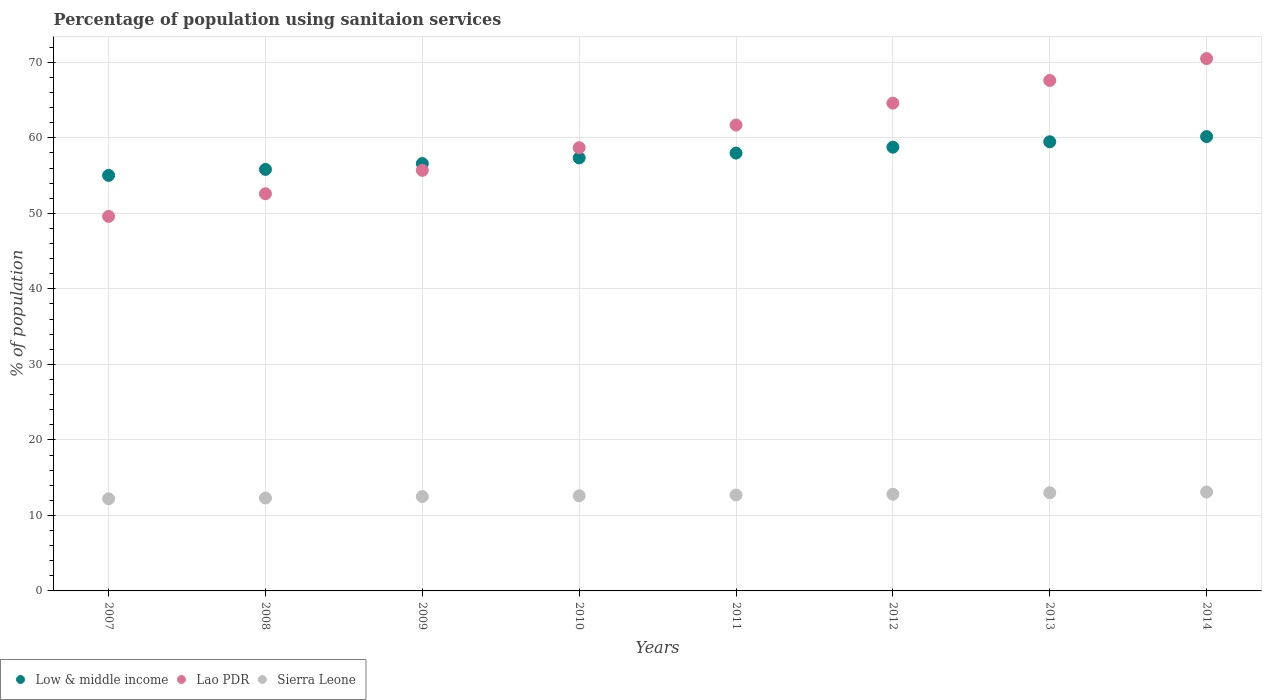How many different coloured dotlines are there?
Keep it short and to the point. 3. Is the number of dotlines equal to the number of legend labels?
Your answer should be compact. Yes. What is the percentage of population using sanitaion services in Low & middle income in 2008?
Give a very brief answer. 55.82. Across all years, what is the maximum percentage of population using sanitaion services in Lao PDR?
Your response must be concise. 70.5. Across all years, what is the minimum percentage of population using sanitaion services in Lao PDR?
Provide a short and direct response. 49.6. In which year was the percentage of population using sanitaion services in Low & middle income maximum?
Make the answer very short. 2014. In which year was the percentage of population using sanitaion services in Low & middle income minimum?
Ensure brevity in your answer.  2007. What is the total percentage of population using sanitaion services in Low & middle income in the graph?
Your answer should be compact. 461.2. What is the difference between the percentage of population using sanitaion services in Lao PDR in 2007 and that in 2013?
Your answer should be compact. -18. What is the difference between the percentage of population using sanitaion services in Low & middle income in 2012 and the percentage of population using sanitaion services in Sierra Leone in 2007?
Make the answer very short. 46.57. What is the average percentage of population using sanitaion services in Low & middle income per year?
Make the answer very short. 57.65. In the year 2012, what is the difference between the percentage of population using sanitaion services in Low & middle income and percentage of population using sanitaion services in Lao PDR?
Give a very brief answer. -5.83. In how many years, is the percentage of population using sanitaion services in Lao PDR greater than 50 %?
Keep it short and to the point. 7. What is the ratio of the percentage of population using sanitaion services in Sierra Leone in 2010 to that in 2013?
Offer a terse response. 0.97. Is the difference between the percentage of population using sanitaion services in Low & middle income in 2007 and 2008 greater than the difference between the percentage of population using sanitaion services in Lao PDR in 2007 and 2008?
Provide a short and direct response. Yes. What is the difference between the highest and the second highest percentage of population using sanitaion services in Sierra Leone?
Your answer should be compact. 0.1. What is the difference between the highest and the lowest percentage of population using sanitaion services in Lao PDR?
Your answer should be compact. 20.9. In how many years, is the percentage of population using sanitaion services in Sierra Leone greater than the average percentage of population using sanitaion services in Sierra Leone taken over all years?
Provide a short and direct response. 4. Is the percentage of population using sanitaion services in Sierra Leone strictly less than the percentage of population using sanitaion services in Low & middle income over the years?
Make the answer very short. Yes. How many dotlines are there?
Keep it short and to the point. 3. Are the values on the major ticks of Y-axis written in scientific E-notation?
Offer a very short reply. No. Does the graph contain any zero values?
Your response must be concise. No. How many legend labels are there?
Keep it short and to the point. 3. How are the legend labels stacked?
Your response must be concise. Horizontal. What is the title of the graph?
Your response must be concise. Percentage of population using sanitaion services. What is the label or title of the Y-axis?
Give a very brief answer. % of population. What is the % of population in Low & middle income in 2007?
Provide a short and direct response. 55.03. What is the % of population of Lao PDR in 2007?
Your answer should be very brief. 49.6. What is the % of population in Low & middle income in 2008?
Provide a succinct answer. 55.82. What is the % of population in Lao PDR in 2008?
Ensure brevity in your answer.  52.6. What is the % of population of Low & middle income in 2009?
Make the answer very short. 56.6. What is the % of population of Lao PDR in 2009?
Your answer should be very brief. 55.7. What is the % of population of Low & middle income in 2010?
Offer a very short reply. 57.34. What is the % of population in Lao PDR in 2010?
Your answer should be very brief. 58.7. What is the % of population of Low & middle income in 2011?
Make the answer very short. 57.98. What is the % of population in Lao PDR in 2011?
Give a very brief answer. 61.7. What is the % of population in Low & middle income in 2012?
Provide a short and direct response. 58.77. What is the % of population in Lao PDR in 2012?
Give a very brief answer. 64.6. What is the % of population in Low & middle income in 2013?
Your response must be concise. 59.48. What is the % of population in Lao PDR in 2013?
Make the answer very short. 67.6. What is the % of population of Sierra Leone in 2013?
Your answer should be compact. 13. What is the % of population of Low & middle income in 2014?
Give a very brief answer. 60.17. What is the % of population of Lao PDR in 2014?
Your response must be concise. 70.5. What is the % of population in Sierra Leone in 2014?
Make the answer very short. 13.1. Across all years, what is the maximum % of population of Low & middle income?
Offer a very short reply. 60.17. Across all years, what is the maximum % of population of Lao PDR?
Make the answer very short. 70.5. Across all years, what is the maximum % of population of Sierra Leone?
Your response must be concise. 13.1. Across all years, what is the minimum % of population in Low & middle income?
Keep it short and to the point. 55.03. Across all years, what is the minimum % of population of Lao PDR?
Provide a short and direct response. 49.6. Across all years, what is the minimum % of population of Sierra Leone?
Ensure brevity in your answer.  12.2. What is the total % of population of Low & middle income in the graph?
Provide a succinct answer. 461.2. What is the total % of population of Lao PDR in the graph?
Your answer should be compact. 481. What is the total % of population of Sierra Leone in the graph?
Your response must be concise. 101.2. What is the difference between the % of population of Low & middle income in 2007 and that in 2008?
Offer a very short reply. -0.79. What is the difference between the % of population in Sierra Leone in 2007 and that in 2008?
Offer a very short reply. -0.1. What is the difference between the % of population of Low & middle income in 2007 and that in 2009?
Make the answer very short. -1.56. What is the difference between the % of population of Lao PDR in 2007 and that in 2009?
Give a very brief answer. -6.1. What is the difference between the % of population of Sierra Leone in 2007 and that in 2009?
Make the answer very short. -0.3. What is the difference between the % of population in Low & middle income in 2007 and that in 2010?
Keep it short and to the point. -2.31. What is the difference between the % of population in Low & middle income in 2007 and that in 2011?
Your answer should be very brief. -2.95. What is the difference between the % of population of Low & middle income in 2007 and that in 2012?
Offer a terse response. -3.74. What is the difference between the % of population in Sierra Leone in 2007 and that in 2012?
Your response must be concise. -0.6. What is the difference between the % of population in Low & middle income in 2007 and that in 2013?
Give a very brief answer. -4.45. What is the difference between the % of population of Sierra Leone in 2007 and that in 2013?
Make the answer very short. -0.8. What is the difference between the % of population of Low & middle income in 2007 and that in 2014?
Ensure brevity in your answer.  -5.14. What is the difference between the % of population of Lao PDR in 2007 and that in 2014?
Your answer should be compact. -20.9. What is the difference between the % of population in Low & middle income in 2008 and that in 2009?
Make the answer very short. -0.77. What is the difference between the % of population in Low & middle income in 2008 and that in 2010?
Your response must be concise. -1.52. What is the difference between the % of population of Sierra Leone in 2008 and that in 2010?
Your response must be concise. -0.3. What is the difference between the % of population of Low & middle income in 2008 and that in 2011?
Provide a short and direct response. -2.16. What is the difference between the % of population in Lao PDR in 2008 and that in 2011?
Your answer should be very brief. -9.1. What is the difference between the % of population in Sierra Leone in 2008 and that in 2011?
Make the answer very short. -0.4. What is the difference between the % of population in Low & middle income in 2008 and that in 2012?
Ensure brevity in your answer.  -2.95. What is the difference between the % of population in Low & middle income in 2008 and that in 2013?
Make the answer very short. -3.66. What is the difference between the % of population in Lao PDR in 2008 and that in 2013?
Provide a succinct answer. -15. What is the difference between the % of population in Sierra Leone in 2008 and that in 2013?
Provide a succinct answer. -0.7. What is the difference between the % of population in Low & middle income in 2008 and that in 2014?
Give a very brief answer. -4.34. What is the difference between the % of population of Lao PDR in 2008 and that in 2014?
Your response must be concise. -17.9. What is the difference between the % of population in Low & middle income in 2009 and that in 2010?
Keep it short and to the point. -0.75. What is the difference between the % of population of Lao PDR in 2009 and that in 2010?
Provide a short and direct response. -3. What is the difference between the % of population in Sierra Leone in 2009 and that in 2010?
Keep it short and to the point. -0.1. What is the difference between the % of population in Low & middle income in 2009 and that in 2011?
Your answer should be compact. -1.39. What is the difference between the % of population of Lao PDR in 2009 and that in 2011?
Provide a short and direct response. -6. What is the difference between the % of population of Sierra Leone in 2009 and that in 2011?
Keep it short and to the point. -0.2. What is the difference between the % of population in Low & middle income in 2009 and that in 2012?
Provide a short and direct response. -2.17. What is the difference between the % of population of Low & middle income in 2009 and that in 2013?
Ensure brevity in your answer.  -2.89. What is the difference between the % of population of Sierra Leone in 2009 and that in 2013?
Your answer should be very brief. -0.5. What is the difference between the % of population of Low & middle income in 2009 and that in 2014?
Provide a succinct answer. -3.57. What is the difference between the % of population in Lao PDR in 2009 and that in 2014?
Make the answer very short. -14.8. What is the difference between the % of population of Low & middle income in 2010 and that in 2011?
Provide a succinct answer. -0.64. What is the difference between the % of population of Lao PDR in 2010 and that in 2011?
Give a very brief answer. -3. What is the difference between the % of population in Sierra Leone in 2010 and that in 2011?
Keep it short and to the point. -0.1. What is the difference between the % of population of Low & middle income in 2010 and that in 2012?
Provide a succinct answer. -1.43. What is the difference between the % of population of Lao PDR in 2010 and that in 2012?
Offer a very short reply. -5.9. What is the difference between the % of population of Sierra Leone in 2010 and that in 2012?
Provide a succinct answer. -0.2. What is the difference between the % of population in Low & middle income in 2010 and that in 2013?
Make the answer very short. -2.14. What is the difference between the % of population of Low & middle income in 2010 and that in 2014?
Give a very brief answer. -2.82. What is the difference between the % of population in Sierra Leone in 2010 and that in 2014?
Provide a short and direct response. -0.5. What is the difference between the % of population in Low & middle income in 2011 and that in 2012?
Offer a very short reply. -0.79. What is the difference between the % of population of Lao PDR in 2011 and that in 2012?
Provide a short and direct response. -2.9. What is the difference between the % of population in Sierra Leone in 2011 and that in 2012?
Make the answer very short. -0.1. What is the difference between the % of population in Low & middle income in 2011 and that in 2013?
Provide a short and direct response. -1.5. What is the difference between the % of population of Lao PDR in 2011 and that in 2013?
Give a very brief answer. -5.9. What is the difference between the % of population in Sierra Leone in 2011 and that in 2013?
Provide a short and direct response. -0.3. What is the difference between the % of population of Low & middle income in 2011 and that in 2014?
Provide a short and direct response. -2.19. What is the difference between the % of population of Low & middle income in 2012 and that in 2013?
Make the answer very short. -0.71. What is the difference between the % of population in Lao PDR in 2012 and that in 2013?
Keep it short and to the point. -3. What is the difference between the % of population in Low & middle income in 2012 and that in 2014?
Provide a succinct answer. -1.4. What is the difference between the % of population in Low & middle income in 2013 and that in 2014?
Offer a very short reply. -0.69. What is the difference between the % of population of Low & middle income in 2007 and the % of population of Lao PDR in 2008?
Your answer should be very brief. 2.43. What is the difference between the % of population of Low & middle income in 2007 and the % of population of Sierra Leone in 2008?
Your answer should be very brief. 42.73. What is the difference between the % of population in Lao PDR in 2007 and the % of population in Sierra Leone in 2008?
Offer a terse response. 37.3. What is the difference between the % of population of Low & middle income in 2007 and the % of population of Lao PDR in 2009?
Provide a succinct answer. -0.67. What is the difference between the % of population of Low & middle income in 2007 and the % of population of Sierra Leone in 2009?
Provide a short and direct response. 42.53. What is the difference between the % of population in Lao PDR in 2007 and the % of population in Sierra Leone in 2009?
Keep it short and to the point. 37.1. What is the difference between the % of population of Low & middle income in 2007 and the % of population of Lao PDR in 2010?
Make the answer very short. -3.67. What is the difference between the % of population in Low & middle income in 2007 and the % of population in Sierra Leone in 2010?
Your response must be concise. 42.43. What is the difference between the % of population of Lao PDR in 2007 and the % of population of Sierra Leone in 2010?
Ensure brevity in your answer.  37. What is the difference between the % of population in Low & middle income in 2007 and the % of population in Lao PDR in 2011?
Provide a succinct answer. -6.67. What is the difference between the % of population in Low & middle income in 2007 and the % of population in Sierra Leone in 2011?
Make the answer very short. 42.33. What is the difference between the % of population in Lao PDR in 2007 and the % of population in Sierra Leone in 2011?
Ensure brevity in your answer.  36.9. What is the difference between the % of population of Low & middle income in 2007 and the % of population of Lao PDR in 2012?
Make the answer very short. -9.57. What is the difference between the % of population of Low & middle income in 2007 and the % of population of Sierra Leone in 2012?
Keep it short and to the point. 42.23. What is the difference between the % of population of Lao PDR in 2007 and the % of population of Sierra Leone in 2012?
Make the answer very short. 36.8. What is the difference between the % of population of Low & middle income in 2007 and the % of population of Lao PDR in 2013?
Your answer should be very brief. -12.57. What is the difference between the % of population in Low & middle income in 2007 and the % of population in Sierra Leone in 2013?
Make the answer very short. 42.03. What is the difference between the % of population in Lao PDR in 2007 and the % of population in Sierra Leone in 2013?
Your answer should be compact. 36.6. What is the difference between the % of population in Low & middle income in 2007 and the % of population in Lao PDR in 2014?
Your answer should be compact. -15.47. What is the difference between the % of population of Low & middle income in 2007 and the % of population of Sierra Leone in 2014?
Offer a very short reply. 41.93. What is the difference between the % of population in Lao PDR in 2007 and the % of population in Sierra Leone in 2014?
Ensure brevity in your answer.  36.5. What is the difference between the % of population of Low & middle income in 2008 and the % of population of Lao PDR in 2009?
Your answer should be compact. 0.12. What is the difference between the % of population of Low & middle income in 2008 and the % of population of Sierra Leone in 2009?
Offer a very short reply. 43.32. What is the difference between the % of population in Lao PDR in 2008 and the % of population in Sierra Leone in 2009?
Make the answer very short. 40.1. What is the difference between the % of population in Low & middle income in 2008 and the % of population in Lao PDR in 2010?
Provide a succinct answer. -2.88. What is the difference between the % of population of Low & middle income in 2008 and the % of population of Sierra Leone in 2010?
Offer a very short reply. 43.22. What is the difference between the % of population in Lao PDR in 2008 and the % of population in Sierra Leone in 2010?
Provide a short and direct response. 40. What is the difference between the % of population of Low & middle income in 2008 and the % of population of Lao PDR in 2011?
Your response must be concise. -5.88. What is the difference between the % of population in Low & middle income in 2008 and the % of population in Sierra Leone in 2011?
Keep it short and to the point. 43.12. What is the difference between the % of population of Lao PDR in 2008 and the % of population of Sierra Leone in 2011?
Provide a succinct answer. 39.9. What is the difference between the % of population in Low & middle income in 2008 and the % of population in Lao PDR in 2012?
Your response must be concise. -8.78. What is the difference between the % of population of Low & middle income in 2008 and the % of population of Sierra Leone in 2012?
Keep it short and to the point. 43.02. What is the difference between the % of population of Lao PDR in 2008 and the % of population of Sierra Leone in 2012?
Your answer should be very brief. 39.8. What is the difference between the % of population of Low & middle income in 2008 and the % of population of Lao PDR in 2013?
Give a very brief answer. -11.78. What is the difference between the % of population of Low & middle income in 2008 and the % of population of Sierra Leone in 2013?
Ensure brevity in your answer.  42.82. What is the difference between the % of population of Lao PDR in 2008 and the % of population of Sierra Leone in 2013?
Your answer should be compact. 39.6. What is the difference between the % of population in Low & middle income in 2008 and the % of population in Lao PDR in 2014?
Offer a terse response. -14.68. What is the difference between the % of population in Low & middle income in 2008 and the % of population in Sierra Leone in 2014?
Make the answer very short. 42.72. What is the difference between the % of population in Lao PDR in 2008 and the % of population in Sierra Leone in 2014?
Ensure brevity in your answer.  39.5. What is the difference between the % of population of Low & middle income in 2009 and the % of population of Lao PDR in 2010?
Offer a very short reply. -2.1. What is the difference between the % of population in Low & middle income in 2009 and the % of population in Sierra Leone in 2010?
Make the answer very short. 44. What is the difference between the % of population of Lao PDR in 2009 and the % of population of Sierra Leone in 2010?
Give a very brief answer. 43.1. What is the difference between the % of population of Low & middle income in 2009 and the % of population of Lao PDR in 2011?
Provide a succinct answer. -5.1. What is the difference between the % of population of Low & middle income in 2009 and the % of population of Sierra Leone in 2011?
Keep it short and to the point. 43.9. What is the difference between the % of population in Lao PDR in 2009 and the % of population in Sierra Leone in 2011?
Make the answer very short. 43. What is the difference between the % of population of Low & middle income in 2009 and the % of population of Lao PDR in 2012?
Offer a terse response. -8. What is the difference between the % of population of Low & middle income in 2009 and the % of population of Sierra Leone in 2012?
Offer a very short reply. 43.8. What is the difference between the % of population in Lao PDR in 2009 and the % of population in Sierra Leone in 2012?
Ensure brevity in your answer.  42.9. What is the difference between the % of population in Low & middle income in 2009 and the % of population in Lao PDR in 2013?
Offer a very short reply. -11. What is the difference between the % of population in Low & middle income in 2009 and the % of population in Sierra Leone in 2013?
Offer a terse response. 43.6. What is the difference between the % of population of Lao PDR in 2009 and the % of population of Sierra Leone in 2013?
Ensure brevity in your answer.  42.7. What is the difference between the % of population of Low & middle income in 2009 and the % of population of Lao PDR in 2014?
Your answer should be very brief. -13.9. What is the difference between the % of population in Low & middle income in 2009 and the % of population in Sierra Leone in 2014?
Your answer should be compact. 43.5. What is the difference between the % of population of Lao PDR in 2009 and the % of population of Sierra Leone in 2014?
Keep it short and to the point. 42.6. What is the difference between the % of population of Low & middle income in 2010 and the % of population of Lao PDR in 2011?
Your answer should be very brief. -4.36. What is the difference between the % of population in Low & middle income in 2010 and the % of population in Sierra Leone in 2011?
Give a very brief answer. 44.64. What is the difference between the % of population in Low & middle income in 2010 and the % of population in Lao PDR in 2012?
Make the answer very short. -7.26. What is the difference between the % of population of Low & middle income in 2010 and the % of population of Sierra Leone in 2012?
Make the answer very short. 44.54. What is the difference between the % of population of Lao PDR in 2010 and the % of population of Sierra Leone in 2012?
Give a very brief answer. 45.9. What is the difference between the % of population of Low & middle income in 2010 and the % of population of Lao PDR in 2013?
Provide a short and direct response. -10.26. What is the difference between the % of population in Low & middle income in 2010 and the % of population in Sierra Leone in 2013?
Offer a terse response. 44.34. What is the difference between the % of population of Lao PDR in 2010 and the % of population of Sierra Leone in 2013?
Offer a very short reply. 45.7. What is the difference between the % of population in Low & middle income in 2010 and the % of population in Lao PDR in 2014?
Offer a terse response. -13.16. What is the difference between the % of population of Low & middle income in 2010 and the % of population of Sierra Leone in 2014?
Your answer should be very brief. 44.24. What is the difference between the % of population of Lao PDR in 2010 and the % of population of Sierra Leone in 2014?
Your answer should be compact. 45.6. What is the difference between the % of population in Low & middle income in 2011 and the % of population in Lao PDR in 2012?
Your answer should be compact. -6.62. What is the difference between the % of population in Low & middle income in 2011 and the % of population in Sierra Leone in 2012?
Make the answer very short. 45.18. What is the difference between the % of population of Lao PDR in 2011 and the % of population of Sierra Leone in 2012?
Offer a terse response. 48.9. What is the difference between the % of population in Low & middle income in 2011 and the % of population in Lao PDR in 2013?
Provide a succinct answer. -9.62. What is the difference between the % of population in Low & middle income in 2011 and the % of population in Sierra Leone in 2013?
Offer a terse response. 44.98. What is the difference between the % of population of Lao PDR in 2011 and the % of population of Sierra Leone in 2013?
Give a very brief answer. 48.7. What is the difference between the % of population in Low & middle income in 2011 and the % of population in Lao PDR in 2014?
Provide a succinct answer. -12.52. What is the difference between the % of population in Low & middle income in 2011 and the % of population in Sierra Leone in 2014?
Offer a terse response. 44.88. What is the difference between the % of population of Lao PDR in 2011 and the % of population of Sierra Leone in 2014?
Offer a very short reply. 48.6. What is the difference between the % of population in Low & middle income in 2012 and the % of population in Lao PDR in 2013?
Your answer should be very brief. -8.83. What is the difference between the % of population of Low & middle income in 2012 and the % of population of Sierra Leone in 2013?
Provide a succinct answer. 45.77. What is the difference between the % of population of Lao PDR in 2012 and the % of population of Sierra Leone in 2013?
Make the answer very short. 51.6. What is the difference between the % of population of Low & middle income in 2012 and the % of population of Lao PDR in 2014?
Your answer should be very brief. -11.73. What is the difference between the % of population in Low & middle income in 2012 and the % of population in Sierra Leone in 2014?
Your answer should be very brief. 45.67. What is the difference between the % of population in Lao PDR in 2012 and the % of population in Sierra Leone in 2014?
Your answer should be very brief. 51.5. What is the difference between the % of population of Low & middle income in 2013 and the % of population of Lao PDR in 2014?
Give a very brief answer. -11.02. What is the difference between the % of population of Low & middle income in 2013 and the % of population of Sierra Leone in 2014?
Ensure brevity in your answer.  46.38. What is the difference between the % of population in Lao PDR in 2013 and the % of population in Sierra Leone in 2014?
Provide a succinct answer. 54.5. What is the average % of population of Low & middle income per year?
Provide a short and direct response. 57.65. What is the average % of population in Lao PDR per year?
Give a very brief answer. 60.12. What is the average % of population of Sierra Leone per year?
Give a very brief answer. 12.65. In the year 2007, what is the difference between the % of population in Low & middle income and % of population in Lao PDR?
Your answer should be compact. 5.43. In the year 2007, what is the difference between the % of population of Low & middle income and % of population of Sierra Leone?
Provide a succinct answer. 42.83. In the year 2007, what is the difference between the % of population of Lao PDR and % of population of Sierra Leone?
Provide a succinct answer. 37.4. In the year 2008, what is the difference between the % of population of Low & middle income and % of population of Lao PDR?
Your response must be concise. 3.22. In the year 2008, what is the difference between the % of population in Low & middle income and % of population in Sierra Leone?
Provide a succinct answer. 43.52. In the year 2008, what is the difference between the % of population in Lao PDR and % of population in Sierra Leone?
Provide a short and direct response. 40.3. In the year 2009, what is the difference between the % of population of Low & middle income and % of population of Lao PDR?
Keep it short and to the point. 0.9. In the year 2009, what is the difference between the % of population of Low & middle income and % of population of Sierra Leone?
Provide a short and direct response. 44.1. In the year 2009, what is the difference between the % of population of Lao PDR and % of population of Sierra Leone?
Ensure brevity in your answer.  43.2. In the year 2010, what is the difference between the % of population in Low & middle income and % of population in Lao PDR?
Give a very brief answer. -1.36. In the year 2010, what is the difference between the % of population in Low & middle income and % of population in Sierra Leone?
Make the answer very short. 44.74. In the year 2010, what is the difference between the % of population of Lao PDR and % of population of Sierra Leone?
Offer a terse response. 46.1. In the year 2011, what is the difference between the % of population in Low & middle income and % of population in Lao PDR?
Keep it short and to the point. -3.72. In the year 2011, what is the difference between the % of population in Low & middle income and % of population in Sierra Leone?
Offer a terse response. 45.28. In the year 2012, what is the difference between the % of population of Low & middle income and % of population of Lao PDR?
Give a very brief answer. -5.83. In the year 2012, what is the difference between the % of population in Low & middle income and % of population in Sierra Leone?
Provide a succinct answer. 45.97. In the year 2012, what is the difference between the % of population of Lao PDR and % of population of Sierra Leone?
Provide a succinct answer. 51.8. In the year 2013, what is the difference between the % of population in Low & middle income and % of population in Lao PDR?
Offer a very short reply. -8.12. In the year 2013, what is the difference between the % of population in Low & middle income and % of population in Sierra Leone?
Your response must be concise. 46.48. In the year 2013, what is the difference between the % of population of Lao PDR and % of population of Sierra Leone?
Provide a succinct answer. 54.6. In the year 2014, what is the difference between the % of population in Low & middle income and % of population in Lao PDR?
Give a very brief answer. -10.33. In the year 2014, what is the difference between the % of population of Low & middle income and % of population of Sierra Leone?
Provide a succinct answer. 47.07. In the year 2014, what is the difference between the % of population in Lao PDR and % of population in Sierra Leone?
Keep it short and to the point. 57.4. What is the ratio of the % of population of Low & middle income in 2007 to that in 2008?
Offer a very short reply. 0.99. What is the ratio of the % of population of Lao PDR in 2007 to that in 2008?
Provide a short and direct response. 0.94. What is the ratio of the % of population of Sierra Leone in 2007 to that in 2008?
Your answer should be very brief. 0.99. What is the ratio of the % of population in Low & middle income in 2007 to that in 2009?
Provide a short and direct response. 0.97. What is the ratio of the % of population of Lao PDR in 2007 to that in 2009?
Make the answer very short. 0.89. What is the ratio of the % of population of Low & middle income in 2007 to that in 2010?
Provide a short and direct response. 0.96. What is the ratio of the % of population of Lao PDR in 2007 to that in 2010?
Your answer should be very brief. 0.84. What is the ratio of the % of population in Sierra Leone in 2007 to that in 2010?
Ensure brevity in your answer.  0.97. What is the ratio of the % of population in Low & middle income in 2007 to that in 2011?
Your answer should be compact. 0.95. What is the ratio of the % of population of Lao PDR in 2007 to that in 2011?
Offer a terse response. 0.8. What is the ratio of the % of population in Sierra Leone in 2007 to that in 2011?
Keep it short and to the point. 0.96. What is the ratio of the % of population of Low & middle income in 2007 to that in 2012?
Ensure brevity in your answer.  0.94. What is the ratio of the % of population of Lao PDR in 2007 to that in 2012?
Your response must be concise. 0.77. What is the ratio of the % of population of Sierra Leone in 2007 to that in 2012?
Provide a short and direct response. 0.95. What is the ratio of the % of population in Low & middle income in 2007 to that in 2013?
Offer a very short reply. 0.93. What is the ratio of the % of population of Lao PDR in 2007 to that in 2013?
Ensure brevity in your answer.  0.73. What is the ratio of the % of population of Sierra Leone in 2007 to that in 2013?
Provide a short and direct response. 0.94. What is the ratio of the % of population of Low & middle income in 2007 to that in 2014?
Your response must be concise. 0.91. What is the ratio of the % of population of Lao PDR in 2007 to that in 2014?
Ensure brevity in your answer.  0.7. What is the ratio of the % of population in Sierra Leone in 2007 to that in 2014?
Your answer should be compact. 0.93. What is the ratio of the % of population of Low & middle income in 2008 to that in 2009?
Provide a short and direct response. 0.99. What is the ratio of the % of population in Lao PDR in 2008 to that in 2009?
Your answer should be compact. 0.94. What is the ratio of the % of population of Low & middle income in 2008 to that in 2010?
Offer a very short reply. 0.97. What is the ratio of the % of population in Lao PDR in 2008 to that in 2010?
Offer a terse response. 0.9. What is the ratio of the % of population of Sierra Leone in 2008 to that in 2010?
Keep it short and to the point. 0.98. What is the ratio of the % of population of Low & middle income in 2008 to that in 2011?
Your answer should be very brief. 0.96. What is the ratio of the % of population of Lao PDR in 2008 to that in 2011?
Make the answer very short. 0.85. What is the ratio of the % of population in Sierra Leone in 2008 to that in 2011?
Give a very brief answer. 0.97. What is the ratio of the % of population in Low & middle income in 2008 to that in 2012?
Your answer should be compact. 0.95. What is the ratio of the % of population of Lao PDR in 2008 to that in 2012?
Make the answer very short. 0.81. What is the ratio of the % of population in Sierra Leone in 2008 to that in 2012?
Ensure brevity in your answer.  0.96. What is the ratio of the % of population in Low & middle income in 2008 to that in 2013?
Give a very brief answer. 0.94. What is the ratio of the % of population in Lao PDR in 2008 to that in 2013?
Your answer should be compact. 0.78. What is the ratio of the % of population of Sierra Leone in 2008 to that in 2013?
Offer a very short reply. 0.95. What is the ratio of the % of population in Low & middle income in 2008 to that in 2014?
Give a very brief answer. 0.93. What is the ratio of the % of population in Lao PDR in 2008 to that in 2014?
Offer a very short reply. 0.75. What is the ratio of the % of population in Sierra Leone in 2008 to that in 2014?
Your answer should be compact. 0.94. What is the ratio of the % of population of Lao PDR in 2009 to that in 2010?
Your answer should be very brief. 0.95. What is the ratio of the % of population in Sierra Leone in 2009 to that in 2010?
Offer a very short reply. 0.99. What is the ratio of the % of population in Low & middle income in 2009 to that in 2011?
Your answer should be compact. 0.98. What is the ratio of the % of population of Lao PDR in 2009 to that in 2011?
Give a very brief answer. 0.9. What is the ratio of the % of population of Sierra Leone in 2009 to that in 2011?
Provide a succinct answer. 0.98. What is the ratio of the % of population in Low & middle income in 2009 to that in 2012?
Offer a very short reply. 0.96. What is the ratio of the % of population of Lao PDR in 2009 to that in 2012?
Give a very brief answer. 0.86. What is the ratio of the % of population of Sierra Leone in 2009 to that in 2012?
Ensure brevity in your answer.  0.98. What is the ratio of the % of population of Low & middle income in 2009 to that in 2013?
Your answer should be compact. 0.95. What is the ratio of the % of population in Lao PDR in 2009 to that in 2013?
Offer a terse response. 0.82. What is the ratio of the % of population of Sierra Leone in 2009 to that in 2013?
Give a very brief answer. 0.96. What is the ratio of the % of population of Low & middle income in 2009 to that in 2014?
Your answer should be compact. 0.94. What is the ratio of the % of population in Lao PDR in 2009 to that in 2014?
Offer a very short reply. 0.79. What is the ratio of the % of population in Sierra Leone in 2009 to that in 2014?
Offer a very short reply. 0.95. What is the ratio of the % of population of Low & middle income in 2010 to that in 2011?
Ensure brevity in your answer.  0.99. What is the ratio of the % of population of Lao PDR in 2010 to that in 2011?
Provide a succinct answer. 0.95. What is the ratio of the % of population of Sierra Leone in 2010 to that in 2011?
Provide a succinct answer. 0.99. What is the ratio of the % of population of Low & middle income in 2010 to that in 2012?
Your answer should be very brief. 0.98. What is the ratio of the % of population in Lao PDR in 2010 to that in 2012?
Ensure brevity in your answer.  0.91. What is the ratio of the % of population in Sierra Leone in 2010 to that in 2012?
Keep it short and to the point. 0.98. What is the ratio of the % of population in Low & middle income in 2010 to that in 2013?
Your response must be concise. 0.96. What is the ratio of the % of population of Lao PDR in 2010 to that in 2013?
Your response must be concise. 0.87. What is the ratio of the % of population of Sierra Leone in 2010 to that in 2013?
Offer a very short reply. 0.97. What is the ratio of the % of population in Low & middle income in 2010 to that in 2014?
Your answer should be very brief. 0.95. What is the ratio of the % of population of Lao PDR in 2010 to that in 2014?
Offer a very short reply. 0.83. What is the ratio of the % of population in Sierra Leone in 2010 to that in 2014?
Ensure brevity in your answer.  0.96. What is the ratio of the % of population of Low & middle income in 2011 to that in 2012?
Provide a succinct answer. 0.99. What is the ratio of the % of population of Lao PDR in 2011 to that in 2012?
Your answer should be very brief. 0.96. What is the ratio of the % of population of Sierra Leone in 2011 to that in 2012?
Offer a terse response. 0.99. What is the ratio of the % of population in Low & middle income in 2011 to that in 2013?
Provide a short and direct response. 0.97. What is the ratio of the % of population of Lao PDR in 2011 to that in 2013?
Offer a terse response. 0.91. What is the ratio of the % of population in Sierra Leone in 2011 to that in 2013?
Offer a very short reply. 0.98. What is the ratio of the % of population of Low & middle income in 2011 to that in 2014?
Ensure brevity in your answer.  0.96. What is the ratio of the % of population of Lao PDR in 2011 to that in 2014?
Provide a succinct answer. 0.88. What is the ratio of the % of population of Sierra Leone in 2011 to that in 2014?
Your answer should be compact. 0.97. What is the ratio of the % of population of Low & middle income in 2012 to that in 2013?
Your response must be concise. 0.99. What is the ratio of the % of population in Lao PDR in 2012 to that in 2013?
Offer a terse response. 0.96. What is the ratio of the % of population in Sierra Leone in 2012 to that in 2013?
Provide a short and direct response. 0.98. What is the ratio of the % of population in Low & middle income in 2012 to that in 2014?
Offer a terse response. 0.98. What is the ratio of the % of population in Lao PDR in 2012 to that in 2014?
Provide a short and direct response. 0.92. What is the ratio of the % of population in Sierra Leone in 2012 to that in 2014?
Offer a very short reply. 0.98. What is the ratio of the % of population in Low & middle income in 2013 to that in 2014?
Provide a succinct answer. 0.99. What is the ratio of the % of population of Lao PDR in 2013 to that in 2014?
Make the answer very short. 0.96. What is the ratio of the % of population in Sierra Leone in 2013 to that in 2014?
Give a very brief answer. 0.99. What is the difference between the highest and the second highest % of population of Low & middle income?
Give a very brief answer. 0.69. What is the difference between the highest and the second highest % of population in Lao PDR?
Your response must be concise. 2.9. What is the difference between the highest and the lowest % of population in Low & middle income?
Ensure brevity in your answer.  5.14. What is the difference between the highest and the lowest % of population of Lao PDR?
Your answer should be very brief. 20.9. What is the difference between the highest and the lowest % of population in Sierra Leone?
Ensure brevity in your answer.  0.9. 